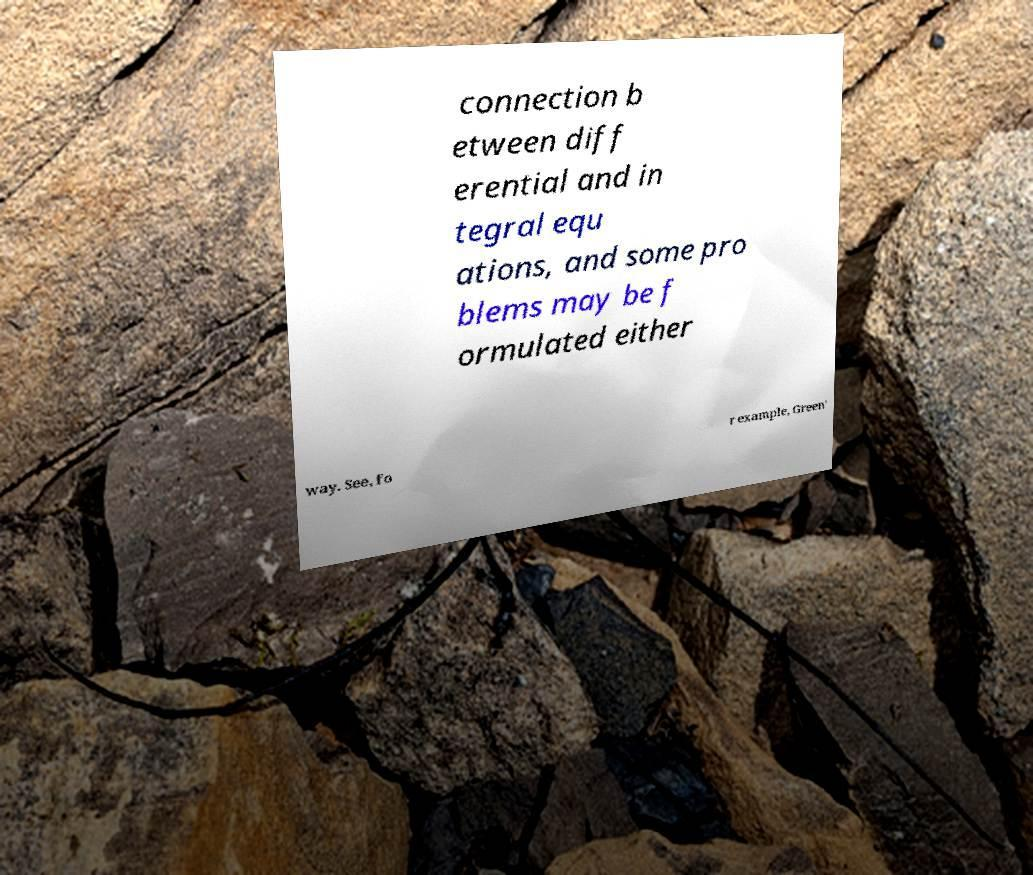Could you assist in decoding the text presented in this image and type it out clearly? connection b etween diff erential and in tegral equ ations, and some pro blems may be f ormulated either way. See, fo r example, Green' 